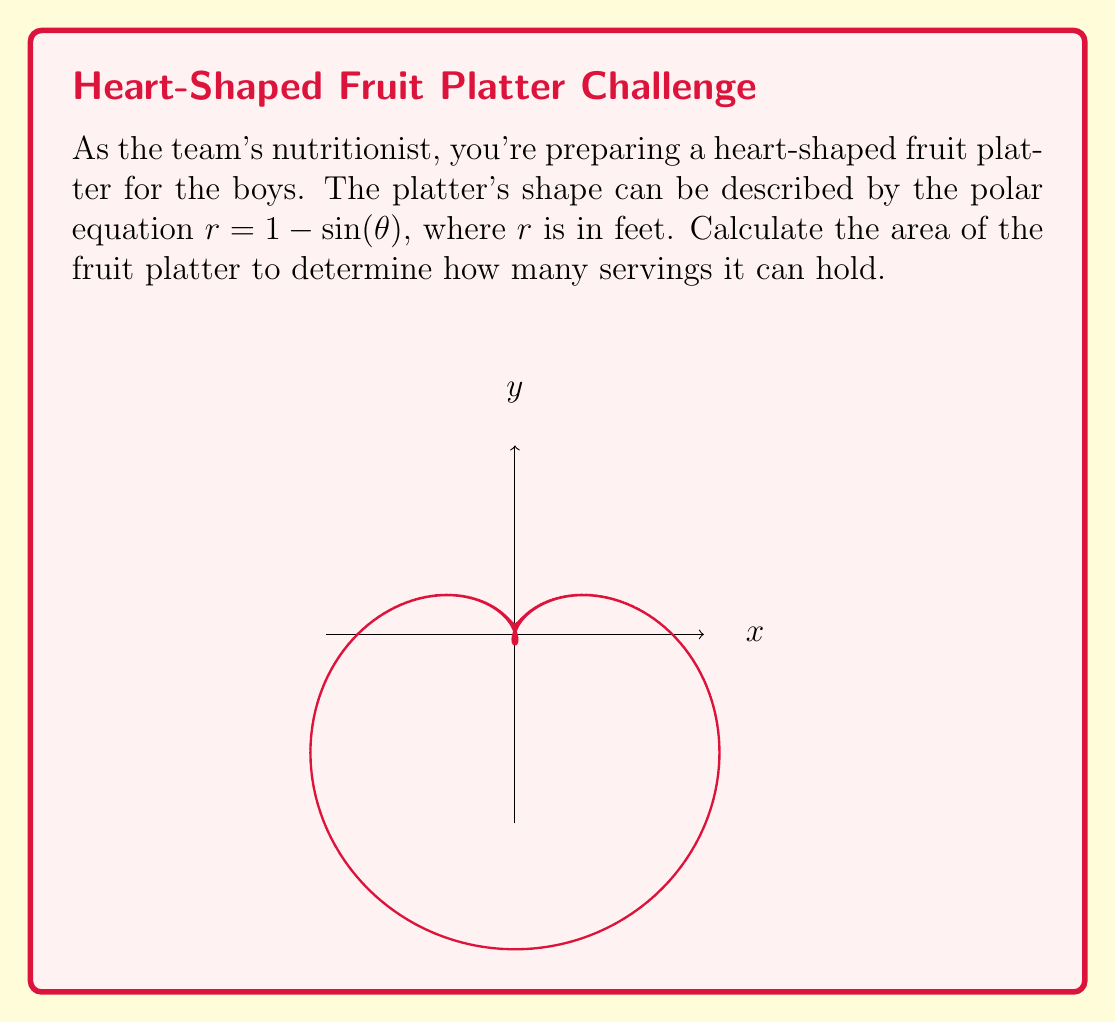Could you help me with this problem? To calculate the area of the heart-shaped fruit platter, we'll use the formula for area in polar coordinates:

$$A = \frac{1}{2} \int_{0}^{2\pi} r^2 d\theta$$

Where $r = 1 - \sin(\theta)$

Step 1: Substitute $r$ into the area formula:
$$A = \frac{1}{2} \int_{0}^{2\pi} (1 - \sin(\theta))^2 d\theta$$

Step 2: Expand the integrand:
$$A = \frac{1}{2} \int_{0}^{2\pi} (1 - 2\sin(\theta) + \sin^2(\theta)) d\theta$$

Step 3: Use the identity $\sin^2(\theta) = \frac{1 - \cos(2\theta)}{2}$:
$$A = \frac{1}{2} \int_{0}^{2\pi} (1 - 2\sin(\theta) + \frac{1 - \cos(2\theta)}{2}) d\theta$$

Step 4: Simplify:
$$A = \frac{1}{2} \int_{0}^{2\pi} (\frac{3}{2} - 2\sin(\theta) - \frac{1}{2}\cos(2\theta)) d\theta$$

Step 5: Integrate term by term:
$$A = \frac{1}{2} [\frac{3}{2}\theta + 2\cos(\theta) - \frac{1}{4}\sin(2\theta)]_{0}^{2\pi}$$

Step 6: Evaluate the definite integral:
$$A = \frac{1}{2} [3\pi + 2(\cos(2\pi) - \cos(0)) - \frac{1}{4}(\sin(4\pi) - \sin(0))]$$

Step 7: Simplify:
$$A = \frac{1}{2} [3\pi + 2(1 - 1) - \frac{1}{4}(0 - 0)] = \frac{3\pi}{2}$$

Therefore, the area of the heart-shaped fruit platter is $\frac{3\pi}{2}$ square feet.
Answer: $\frac{3\pi}{2}$ sq ft 